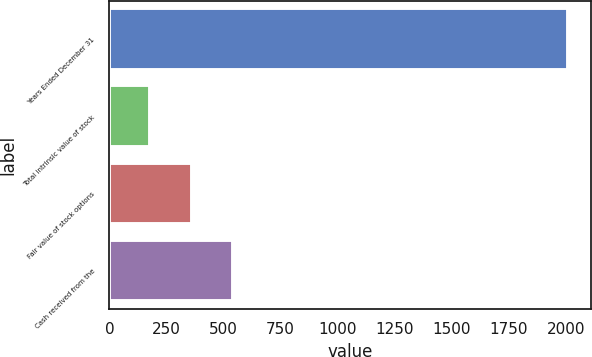Convert chart. <chart><loc_0><loc_0><loc_500><loc_500><bar_chart><fcel>Years Ended December 31<fcel>Total intrinsic value of stock<fcel>Fair value of stock options<fcel>Cash received from the<nl><fcel>2010<fcel>177<fcel>360.3<fcel>543.6<nl></chart> 